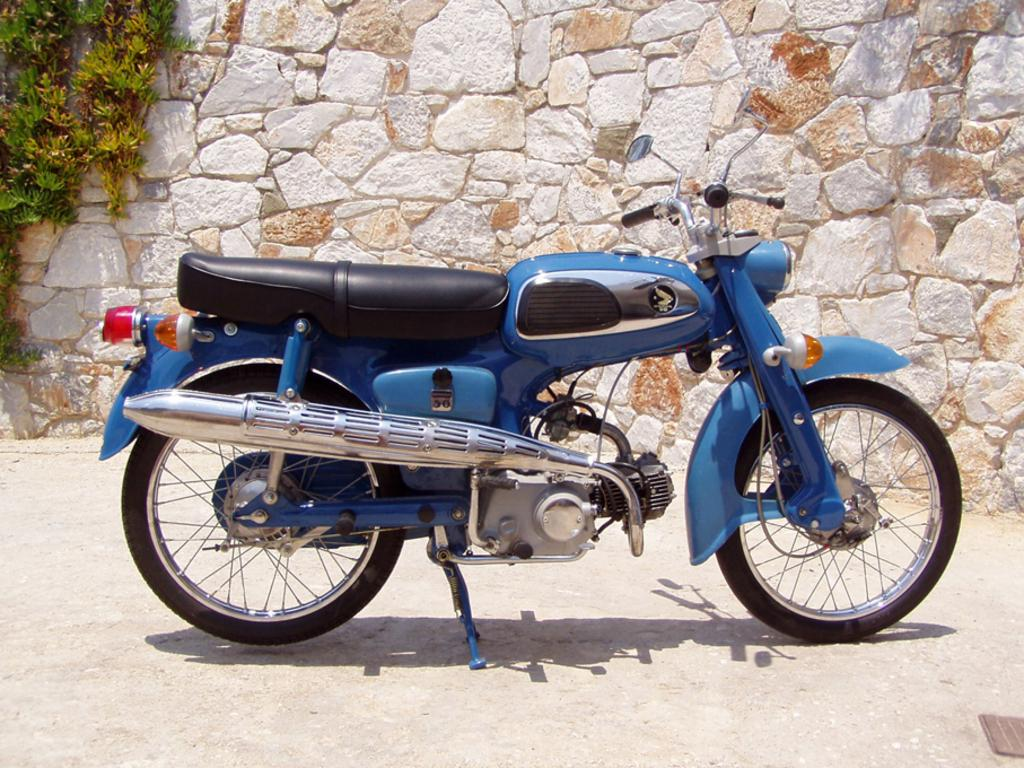What is the main subject of the image? The main subject of the image is a motorcycle. What is located behind the motorcycle in the image? There is a stone wall behind the motorcycle. What type of vegetation can be seen in the image? Leaves are present in the image. What is the income of the actor standing next to the motorcycle in the image? There is no actor present in the image, and therefore no information about their income can be provided. 